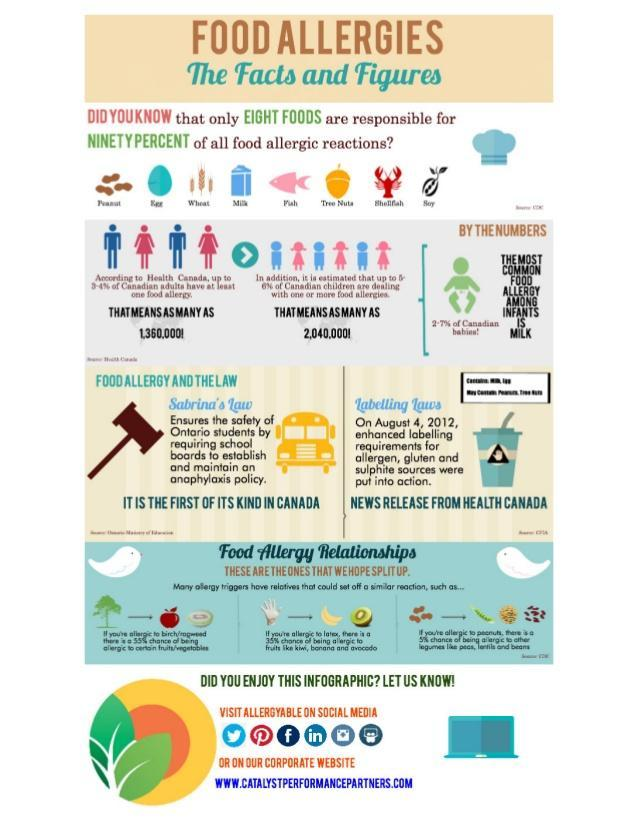How many social media network icons are shown in this infographic?
Answer the question with a short phrase. 6 